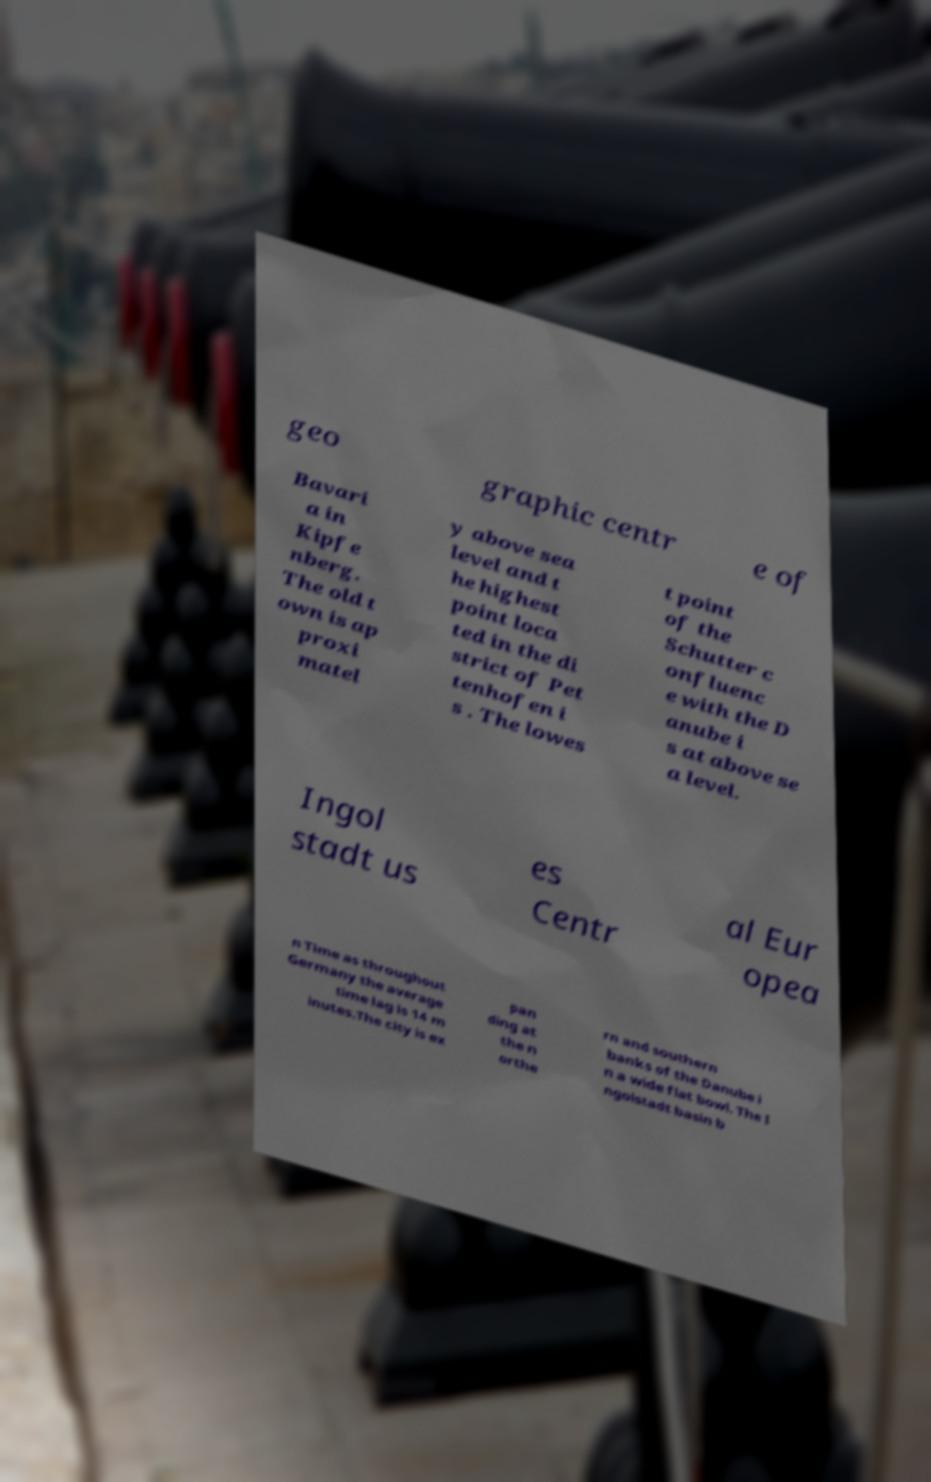Please read and relay the text visible in this image. What does it say? geo graphic centr e of Bavari a in Kipfe nberg. The old t own is ap proxi matel y above sea level and t he highest point loca ted in the di strict of Pet tenhofen i s . The lowes t point of the Schutter c onfluenc e with the D anube i s at above se a level. Ingol stadt us es Centr al Eur opea n Time as throughout Germany the average time lag is 14 m inutes.The city is ex pan ding at the n orthe rn and southern banks of the Danube i n a wide flat bowl. The I ngolstadt basin b 